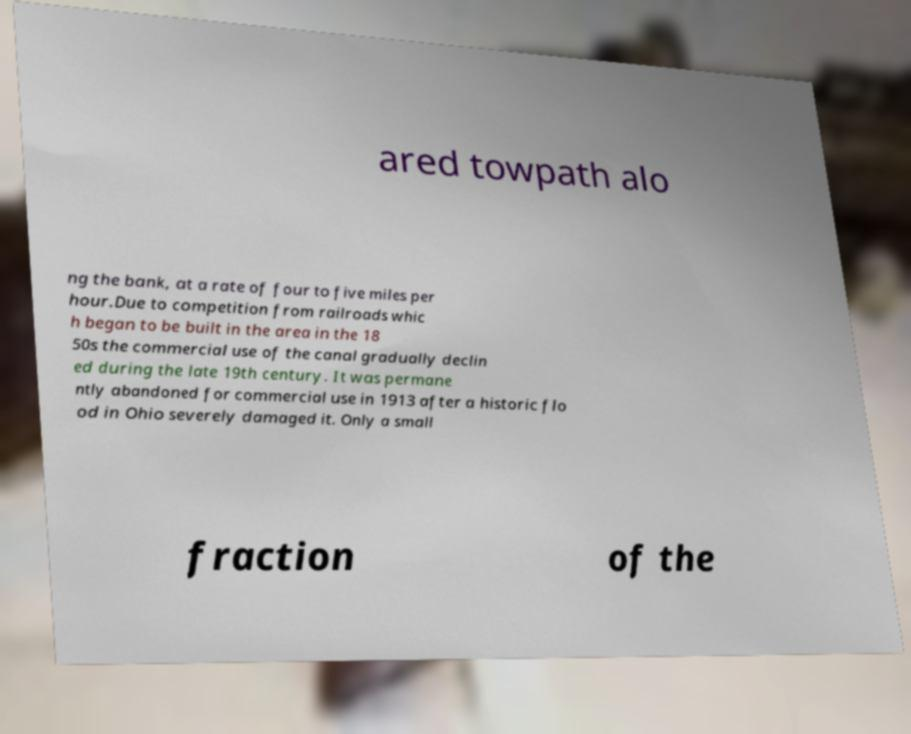What messages or text are displayed in this image? I need them in a readable, typed format. ared towpath alo ng the bank, at a rate of four to five miles per hour.Due to competition from railroads whic h began to be built in the area in the 18 50s the commercial use of the canal gradually declin ed during the late 19th century. It was permane ntly abandoned for commercial use in 1913 after a historic flo od in Ohio severely damaged it. Only a small fraction of the 